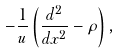Convert formula to latex. <formula><loc_0><loc_0><loc_500><loc_500>- \frac { 1 } { u } \left ( \frac { d ^ { 2 } } { d x ^ { 2 } } - \rho \right ) ,</formula> 